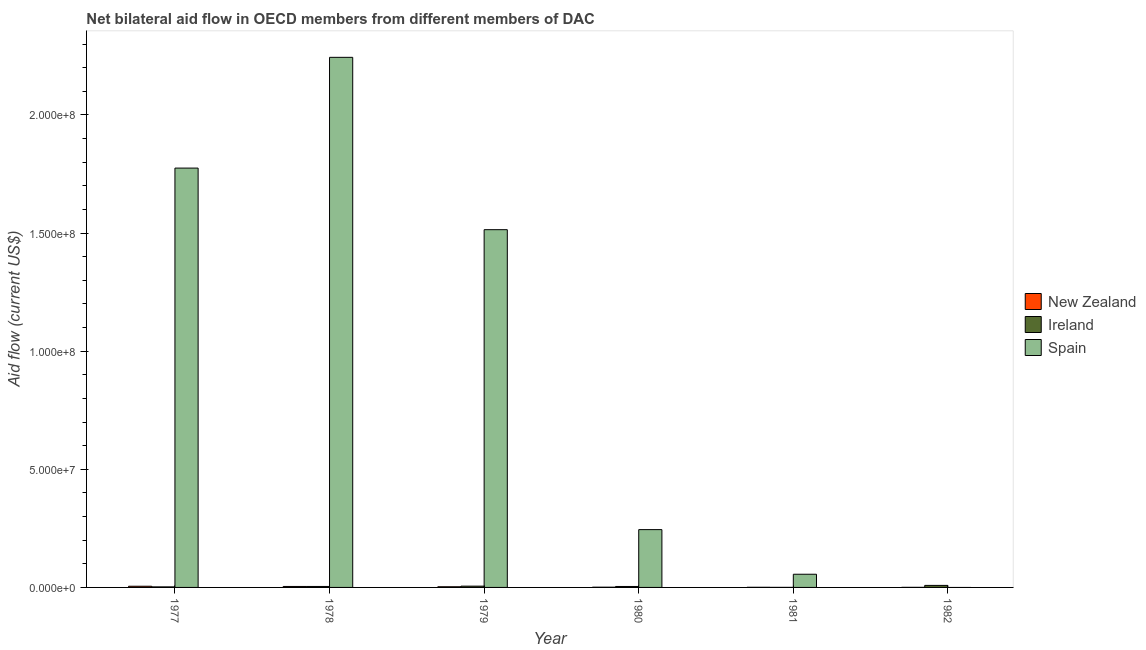How many groups of bars are there?
Make the answer very short. 6. Are the number of bars per tick equal to the number of legend labels?
Your response must be concise. No. Are the number of bars on each tick of the X-axis equal?
Keep it short and to the point. No. How many bars are there on the 2nd tick from the right?
Make the answer very short. 3. What is the label of the 5th group of bars from the left?
Your answer should be very brief. 1981. What is the amount of aid provided by ireland in 1982?
Your answer should be compact. 8.60e+05. Across all years, what is the maximum amount of aid provided by ireland?
Provide a short and direct response. 8.60e+05. Across all years, what is the minimum amount of aid provided by new zealand?
Make the answer very short. 3.00e+04. In which year was the amount of aid provided by spain maximum?
Provide a short and direct response. 1978. What is the total amount of aid provided by new zealand in the graph?
Provide a succinct answer. 1.37e+06. What is the difference between the amount of aid provided by ireland in 1979 and that in 1980?
Provide a short and direct response. 1.40e+05. What is the difference between the amount of aid provided by new zealand in 1982 and the amount of aid provided by ireland in 1977?
Make the answer very short. -4.70e+05. What is the average amount of aid provided by spain per year?
Keep it short and to the point. 9.72e+07. In how many years, is the amount of aid provided by spain greater than 10000000 US$?
Your answer should be very brief. 4. What is the ratio of the amount of aid provided by new zealand in 1980 to that in 1982?
Provide a succinct answer. 3.33. Is the amount of aid provided by new zealand in 1980 less than that in 1982?
Provide a short and direct response. No. What is the difference between the highest and the second highest amount of aid provided by spain?
Ensure brevity in your answer.  4.69e+07. What is the difference between the highest and the lowest amount of aid provided by new zealand?
Your answer should be very brief. 4.70e+05. In how many years, is the amount of aid provided by ireland greater than the average amount of aid provided by ireland taken over all years?
Give a very brief answer. 2. Is the sum of the amount of aid provided by spain in 1977 and 1979 greater than the maximum amount of aid provided by ireland across all years?
Make the answer very short. Yes. Is it the case that in every year, the sum of the amount of aid provided by new zealand and amount of aid provided by ireland is greater than the amount of aid provided by spain?
Offer a very short reply. No. Are all the bars in the graph horizontal?
Provide a succinct answer. No. How many years are there in the graph?
Offer a very short reply. 6. Are the values on the major ticks of Y-axis written in scientific E-notation?
Provide a succinct answer. Yes. Does the graph contain any zero values?
Give a very brief answer. Yes. What is the title of the graph?
Make the answer very short. Net bilateral aid flow in OECD members from different members of DAC. What is the label or title of the Y-axis?
Provide a succinct answer. Aid flow (current US$). What is the Aid flow (current US$) in New Zealand in 1977?
Offer a very short reply. 5.00e+05. What is the Aid flow (current US$) of Ireland in 1977?
Your answer should be very brief. 2.30e+05. What is the Aid flow (current US$) of Spain in 1977?
Your answer should be very brief. 1.78e+08. What is the Aid flow (current US$) in Ireland in 1978?
Your response must be concise. 4.10e+05. What is the Aid flow (current US$) of Spain in 1978?
Your answer should be compact. 2.24e+08. What is the Aid flow (current US$) in Ireland in 1979?
Your answer should be very brief. 5.40e+05. What is the Aid flow (current US$) in Spain in 1979?
Keep it short and to the point. 1.51e+08. What is the Aid flow (current US$) of Spain in 1980?
Offer a very short reply. 2.45e+07. What is the Aid flow (current US$) in New Zealand in 1981?
Make the answer very short. 5.00e+04. What is the Aid flow (current US$) in Spain in 1981?
Provide a short and direct response. 5.58e+06. What is the Aid flow (current US$) in Ireland in 1982?
Offer a terse response. 8.60e+05. Across all years, what is the maximum Aid flow (current US$) in New Zealand?
Offer a terse response. 5.00e+05. Across all years, what is the maximum Aid flow (current US$) of Ireland?
Ensure brevity in your answer.  8.60e+05. Across all years, what is the maximum Aid flow (current US$) in Spain?
Provide a short and direct response. 2.24e+08. Across all years, what is the minimum Aid flow (current US$) of Ireland?
Your answer should be very brief. 2.00e+04. What is the total Aid flow (current US$) in New Zealand in the graph?
Ensure brevity in your answer.  1.37e+06. What is the total Aid flow (current US$) of Ireland in the graph?
Offer a very short reply. 2.46e+06. What is the total Aid flow (current US$) in Spain in the graph?
Provide a short and direct response. 5.83e+08. What is the difference between the Aid flow (current US$) of Spain in 1977 and that in 1978?
Ensure brevity in your answer.  -4.69e+07. What is the difference between the Aid flow (current US$) of New Zealand in 1977 and that in 1979?
Your response must be concise. 2.20e+05. What is the difference between the Aid flow (current US$) of Ireland in 1977 and that in 1979?
Provide a short and direct response. -3.10e+05. What is the difference between the Aid flow (current US$) of Spain in 1977 and that in 1979?
Offer a very short reply. 2.61e+07. What is the difference between the Aid flow (current US$) in Spain in 1977 and that in 1980?
Make the answer very short. 1.53e+08. What is the difference between the Aid flow (current US$) of Ireland in 1977 and that in 1981?
Give a very brief answer. 2.10e+05. What is the difference between the Aid flow (current US$) in Spain in 1977 and that in 1981?
Make the answer very short. 1.72e+08. What is the difference between the Aid flow (current US$) of Ireland in 1977 and that in 1982?
Your response must be concise. -6.30e+05. What is the difference between the Aid flow (current US$) in Spain in 1978 and that in 1979?
Your answer should be compact. 7.30e+07. What is the difference between the Aid flow (current US$) in Spain in 1978 and that in 1980?
Ensure brevity in your answer.  2.00e+08. What is the difference between the Aid flow (current US$) of New Zealand in 1978 and that in 1981?
Your response must be concise. 3.60e+05. What is the difference between the Aid flow (current US$) in Ireland in 1978 and that in 1981?
Your answer should be very brief. 3.90e+05. What is the difference between the Aid flow (current US$) in Spain in 1978 and that in 1981?
Ensure brevity in your answer.  2.19e+08. What is the difference between the Aid flow (current US$) in Ireland in 1978 and that in 1982?
Offer a terse response. -4.50e+05. What is the difference between the Aid flow (current US$) of New Zealand in 1979 and that in 1980?
Give a very brief answer. 1.80e+05. What is the difference between the Aid flow (current US$) in Spain in 1979 and that in 1980?
Provide a succinct answer. 1.27e+08. What is the difference between the Aid flow (current US$) in New Zealand in 1979 and that in 1981?
Ensure brevity in your answer.  2.30e+05. What is the difference between the Aid flow (current US$) of Ireland in 1979 and that in 1981?
Your answer should be compact. 5.20e+05. What is the difference between the Aid flow (current US$) of Spain in 1979 and that in 1981?
Give a very brief answer. 1.46e+08. What is the difference between the Aid flow (current US$) in Ireland in 1979 and that in 1982?
Your answer should be very brief. -3.20e+05. What is the difference between the Aid flow (current US$) in Ireland in 1980 and that in 1981?
Provide a succinct answer. 3.80e+05. What is the difference between the Aid flow (current US$) in Spain in 1980 and that in 1981?
Your response must be concise. 1.89e+07. What is the difference between the Aid flow (current US$) of Ireland in 1980 and that in 1982?
Your answer should be very brief. -4.60e+05. What is the difference between the Aid flow (current US$) in New Zealand in 1981 and that in 1982?
Offer a very short reply. 2.00e+04. What is the difference between the Aid flow (current US$) in Ireland in 1981 and that in 1982?
Keep it short and to the point. -8.40e+05. What is the difference between the Aid flow (current US$) in New Zealand in 1977 and the Aid flow (current US$) in Spain in 1978?
Offer a terse response. -2.24e+08. What is the difference between the Aid flow (current US$) of Ireland in 1977 and the Aid flow (current US$) of Spain in 1978?
Offer a terse response. -2.24e+08. What is the difference between the Aid flow (current US$) in New Zealand in 1977 and the Aid flow (current US$) in Ireland in 1979?
Keep it short and to the point. -4.00e+04. What is the difference between the Aid flow (current US$) of New Zealand in 1977 and the Aid flow (current US$) of Spain in 1979?
Give a very brief answer. -1.51e+08. What is the difference between the Aid flow (current US$) in Ireland in 1977 and the Aid flow (current US$) in Spain in 1979?
Keep it short and to the point. -1.51e+08. What is the difference between the Aid flow (current US$) of New Zealand in 1977 and the Aid flow (current US$) of Spain in 1980?
Your answer should be very brief. -2.40e+07. What is the difference between the Aid flow (current US$) in Ireland in 1977 and the Aid flow (current US$) in Spain in 1980?
Give a very brief answer. -2.42e+07. What is the difference between the Aid flow (current US$) of New Zealand in 1977 and the Aid flow (current US$) of Spain in 1981?
Your answer should be very brief. -5.08e+06. What is the difference between the Aid flow (current US$) of Ireland in 1977 and the Aid flow (current US$) of Spain in 1981?
Your answer should be very brief. -5.35e+06. What is the difference between the Aid flow (current US$) of New Zealand in 1977 and the Aid flow (current US$) of Ireland in 1982?
Your answer should be compact. -3.60e+05. What is the difference between the Aid flow (current US$) in New Zealand in 1978 and the Aid flow (current US$) in Spain in 1979?
Keep it short and to the point. -1.51e+08. What is the difference between the Aid flow (current US$) of Ireland in 1978 and the Aid flow (current US$) of Spain in 1979?
Keep it short and to the point. -1.51e+08. What is the difference between the Aid flow (current US$) in New Zealand in 1978 and the Aid flow (current US$) in Spain in 1980?
Your answer should be compact. -2.41e+07. What is the difference between the Aid flow (current US$) of Ireland in 1978 and the Aid flow (current US$) of Spain in 1980?
Ensure brevity in your answer.  -2.41e+07. What is the difference between the Aid flow (current US$) in New Zealand in 1978 and the Aid flow (current US$) in Ireland in 1981?
Your answer should be compact. 3.90e+05. What is the difference between the Aid flow (current US$) in New Zealand in 1978 and the Aid flow (current US$) in Spain in 1981?
Ensure brevity in your answer.  -5.17e+06. What is the difference between the Aid flow (current US$) in Ireland in 1978 and the Aid flow (current US$) in Spain in 1981?
Offer a terse response. -5.17e+06. What is the difference between the Aid flow (current US$) in New Zealand in 1978 and the Aid flow (current US$) in Ireland in 1982?
Your answer should be very brief. -4.50e+05. What is the difference between the Aid flow (current US$) of New Zealand in 1979 and the Aid flow (current US$) of Spain in 1980?
Your response must be concise. -2.42e+07. What is the difference between the Aid flow (current US$) in Ireland in 1979 and the Aid flow (current US$) in Spain in 1980?
Make the answer very short. -2.39e+07. What is the difference between the Aid flow (current US$) of New Zealand in 1979 and the Aid flow (current US$) of Ireland in 1981?
Offer a terse response. 2.60e+05. What is the difference between the Aid flow (current US$) of New Zealand in 1979 and the Aid flow (current US$) of Spain in 1981?
Offer a terse response. -5.30e+06. What is the difference between the Aid flow (current US$) of Ireland in 1979 and the Aid flow (current US$) of Spain in 1981?
Your response must be concise. -5.04e+06. What is the difference between the Aid flow (current US$) of New Zealand in 1979 and the Aid flow (current US$) of Ireland in 1982?
Provide a succinct answer. -5.80e+05. What is the difference between the Aid flow (current US$) in New Zealand in 1980 and the Aid flow (current US$) in Ireland in 1981?
Your answer should be compact. 8.00e+04. What is the difference between the Aid flow (current US$) of New Zealand in 1980 and the Aid flow (current US$) of Spain in 1981?
Your answer should be compact. -5.48e+06. What is the difference between the Aid flow (current US$) in Ireland in 1980 and the Aid flow (current US$) in Spain in 1981?
Provide a succinct answer. -5.18e+06. What is the difference between the Aid flow (current US$) of New Zealand in 1980 and the Aid flow (current US$) of Ireland in 1982?
Keep it short and to the point. -7.60e+05. What is the difference between the Aid flow (current US$) in New Zealand in 1981 and the Aid flow (current US$) in Ireland in 1982?
Offer a terse response. -8.10e+05. What is the average Aid flow (current US$) in New Zealand per year?
Make the answer very short. 2.28e+05. What is the average Aid flow (current US$) in Ireland per year?
Provide a short and direct response. 4.10e+05. What is the average Aid flow (current US$) in Spain per year?
Offer a terse response. 9.72e+07. In the year 1977, what is the difference between the Aid flow (current US$) of New Zealand and Aid flow (current US$) of Spain?
Make the answer very short. -1.77e+08. In the year 1977, what is the difference between the Aid flow (current US$) in Ireland and Aid flow (current US$) in Spain?
Make the answer very short. -1.77e+08. In the year 1978, what is the difference between the Aid flow (current US$) of New Zealand and Aid flow (current US$) of Ireland?
Your answer should be very brief. 0. In the year 1978, what is the difference between the Aid flow (current US$) in New Zealand and Aid flow (current US$) in Spain?
Your answer should be very brief. -2.24e+08. In the year 1978, what is the difference between the Aid flow (current US$) of Ireland and Aid flow (current US$) of Spain?
Keep it short and to the point. -2.24e+08. In the year 1979, what is the difference between the Aid flow (current US$) in New Zealand and Aid flow (current US$) in Spain?
Your answer should be very brief. -1.51e+08. In the year 1979, what is the difference between the Aid flow (current US$) of Ireland and Aid flow (current US$) of Spain?
Provide a succinct answer. -1.51e+08. In the year 1980, what is the difference between the Aid flow (current US$) in New Zealand and Aid flow (current US$) in Ireland?
Provide a short and direct response. -3.00e+05. In the year 1980, what is the difference between the Aid flow (current US$) of New Zealand and Aid flow (current US$) of Spain?
Offer a very short reply. -2.44e+07. In the year 1980, what is the difference between the Aid flow (current US$) in Ireland and Aid flow (current US$) in Spain?
Offer a terse response. -2.41e+07. In the year 1981, what is the difference between the Aid flow (current US$) of New Zealand and Aid flow (current US$) of Ireland?
Ensure brevity in your answer.  3.00e+04. In the year 1981, what is the difference between the Aid flow (current US$) of New Zealand and Aid flow (current US$) of Spain?
Ensure brevity in your answer.  -5.53e+06. In the year 1981, what is the difference between the Aid flow (current US$) in Ireland and Aid flow (current US$) in Spain?
Offer a terse response. -5.56e+06. In the year 1982, what is the difference between the Aid flow (current US$) in New Zealand and Aid flow (current US$) in Ireland?
Ensure brevity in your answer.  -8.30e+05. What is the ratio of the Aid flow (current US$) in New Zealand in 1977 to that in 1978?
Give a very brief answer. 1.22. What is the ratio of the Aid flow (current US$) of Ireland in 1977 to that in 1978?
Make the answer very short. 0.56. What is the ratio of the Aid flow (current US$) in Spain in 1977 to that in 1978?
Offer a very short reply. 0.79. What is the ratio of the Aid flow (current US$) in New Zealand in 1977 to that in 1979?
Offer a terse response. 1.79. What is the ratio of the Aid flow (current US$) of Ireland in 1977 to that in 1979?
Your response must be concise. 0.43. What is the ratio of the Aid flow (current US$) in Spain in 1977 to that in 1979?
Make the answer very short. 1.17. What is the ratio of the Aid flow (current US$) in New Zealand in 1977 to that in 1980?
Make the answer very short. 5. What is the ratio of the Aid flow (current US$) of Ireland in 1977 to that in 1980?
Give a very brief answer. 0.57. What is the ratio of the Aid flow (current US$) in Spain in 1977 to that in 1980?
Your response must be concise. 7.25. What is the ratio of the Aid flow (current US$) of New Zealand in 1977 to that in 1981?
Your answer should be very brief. 10. What is the ratio of the Aid flow (current US$) in Spain in 1977 to that in 1981?
Provide a short and direct response. 31.81. What is the ratio of the Aid flow (current US$) of New Zealand in 1977 to that in 1982?
Give a very brief answer. 16.67. What is the ratio of the Aid flow (current US$) in Ireland in 1977 to that in 1982?
Offer a terse response. 0.27. What is the ratio of the Aid flow (current US$) in New Zealand in 1978 to that in 1979?
Your answer should be compact. 1.46. What is the ratio of the Aid flow (current US$) in Ireland in 1978 to that in 1979?
Ensure brevity in your answer.  0.76. What is the ratio of the Aid flow (current US$) in Spain in 1978 to that in 1979?
Provide a short and direct response. 1.48. What is the ratio of the Aid flow (current US$) in New Zealand in 1978 to that in 1980?
Your response must be concise. 4.1. What is the ratio of the Aid flow (current US$) of Spain in 1978 to that in 1980?
Give a very brief answer. 9.17. What is the ratio of the Aid flow (current US$) in New Zealand in 1978 to that in 1981?
Give a very brief answer. 8.2. What is the ratio of the Aid flow (current US$) of Spain in 1978 to that in 1981?
Your response must be concise. 40.21. What is the ratio of the Aid flow (current US$) of New Zealand in 1978 to that in 1982?
Your answer should be very brief. 13.67. What is the ratio of the Aid flow (current US$) in Ireland in 1978 to that in 1982?
Keep it short and to the point. 0.48. What is the ratio of the Aid flow (current US$) in Ireland in 1979 to that in 1980?
Give a very brief answer. 1.35. What is the ratio of the Aid flow (current US$) of Spain in 1979 to that in 1980?
Your answer should be compact. 6.19. What is the ratio of the Aid flow (current US$) of Spain in 1979 to that in 1981?
Your answer should be compact. 27.14. What is the ratio of the Aid flow (current US$) in New Zealand in 1979 to that in 1982?
Your answer should be very brief. 9.33. What is the ratio of the Aid flow (current US$) in Ireland in 1979 to that in 1982?
Your answer should be very brief. 0.63. What is the ratio of the Aid flow (current US$) in Spain in 1980 to that in 1981?
Make the answer very short. 4.39. What is the ratio of the Aid flow (current US$) of Ireland in 1980 to that in 1982?
Your answer should be very brief. 0.47. What is the ratio of the Aid flow (current US$) in Ireland in 1981 to that in 1982?
Keep it short and to the point. 0.02. What is the difference between the highest and the second highest Aid flow (current US$) in New Zealand?
Offer a terse response. 9.00e+04. What is the difference between the highest and the second highest Aid flow (current US$) of Ireland?
Make the answer very short. 3.20e+05. What is the difference between the highest and the second highest Aid flow (current US$) of Spain?
Your response must be concise. 4.69e+07. What is the difference between the highest and the lowest Aid flow (current US$) of New Zealand?
Provide a short and direct response. 4.70e+05. What is the difference between the highest and the lowest Aid flow (current US$) of Ireland?
Your answer should be compact. 8.40e+05. What is the difference between the highest and the lowest Aid flow (current US$) in Spain?
Offer a very short reply. 2.24e+08. 